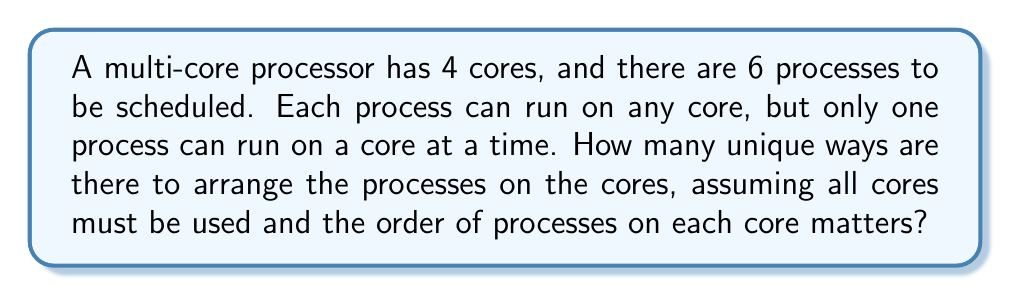Can you answer this question? Let's approach this step-by-step:

1) First, we need to distribute the processes among the cores. This is a partition problem.

2) We need to partition 6 processes into 4 non-empty parts (as all cores must be used). This can be done in $S(6,4)$ ways, where $S(n,k)$ is the Stirling number of the second kind.

3) $S(6,4) = 65$

4) However, for each partition, we need to consider the permutations of processes within each core.

5) For a partition of type $(a,b,c,d)$ where $a+b+c+d=6$, the number of permutations is:

   $$\frac{6!}{a!b!c!d!}$$

6) We need to sum this over all possible partitions. The possible partitions are:
   $(3,1,1,1)$, $(2,2,1,1)$

7) For $(3,1,1,1)$:
   Number of permutations = $\frac{6!}{3!1!1!1!} = 120$
   This can be arranged in $4!$ ways on 4 cores = $120 \times 24 = 2880$

8) For $(2,2,1,1)$:
   Number of permutations = $\frac{6!}{2!2!1!1!} = 180$
   This can be arranged in $\frac{4!}{2!} = 12$ ways on 4 cores = $180 \times 12 = 2160$

9) Total number of unique arrangements = $2880 + 2160 = 5040$
Answer: 5040 